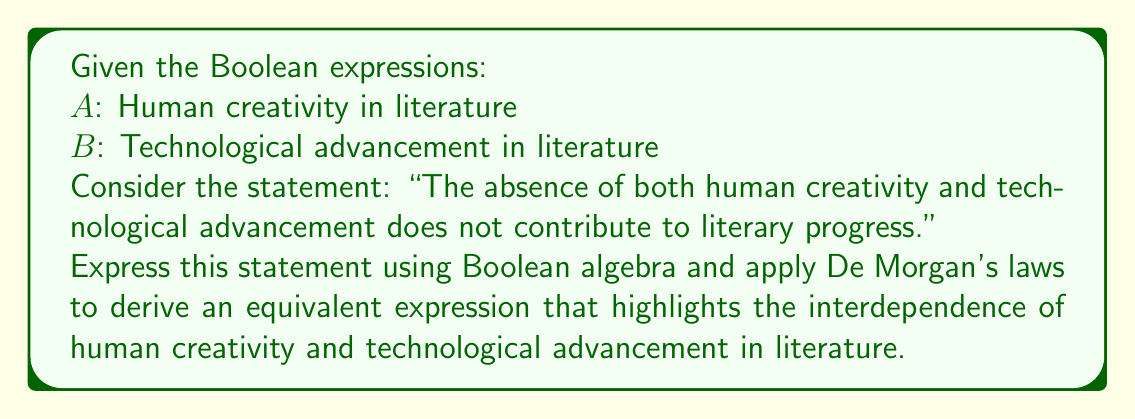Could you help me with this problem? 1. First, let's express the given statement in Boolean algebra:
   $\overline{(\overline{A} \cdot \overline{B})}$

2. Apply De Morgan's first law to this expression:
   $\overline{(\overline{A} \cdot \overline{B})} = A + B$

3. The resulting expression $A + B$ can be interpreted as:
   "Either human creativity OR technological advancement (or both) contributes to literary progress."

4. This transformation reveals that the original statement is logically equivalent to asserting that literary progress requires at least one of these elements (human creativity or technological advancement).

5. From a pragmatist perspective, this result suggests that while human creativity remains essential, technological advancements can also play a role in literary progress. It doesn't negate the importance of human creativity but rather implies a potential synergy between human and technological contributions to literature.

6. The application of De Morgan's law in this context demonstrates how Boolean algebra can be used to analyze and reframe complex relationships in literary studies, providing a logical framework for examining the interplay between human and technological factors in creative processes.
Answer: $A + B$ 